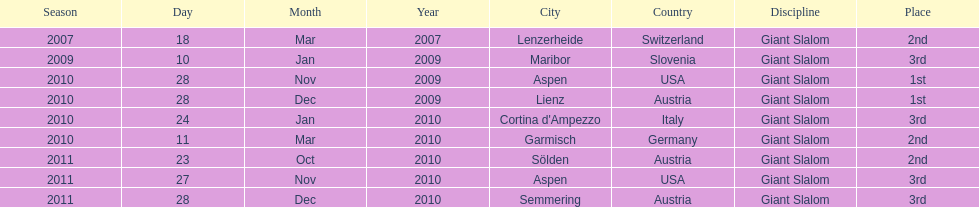Where was her first win? Aspen, USA. 